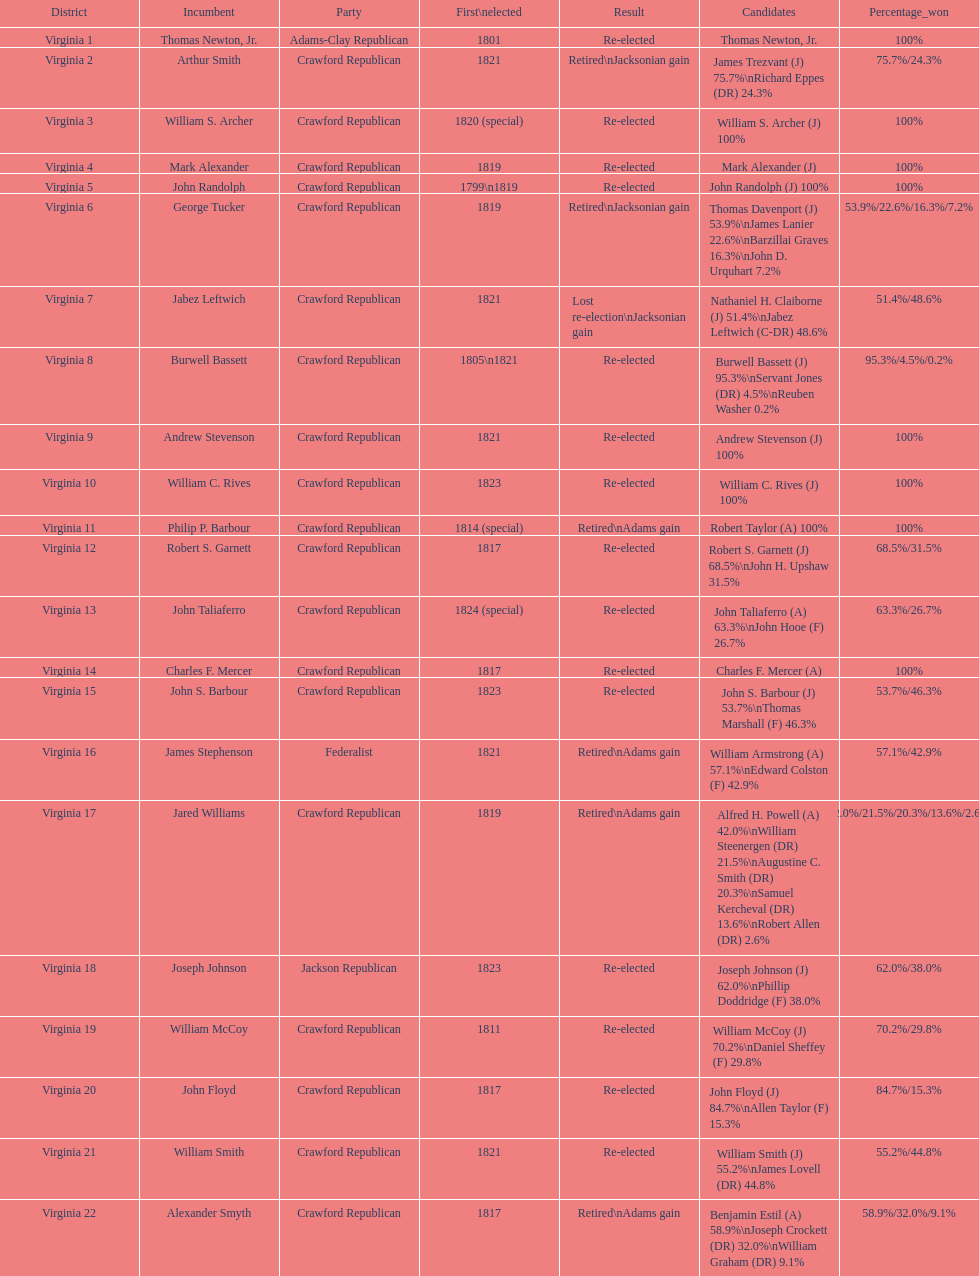What are the number of times re-elected is listed as the result? 15. 